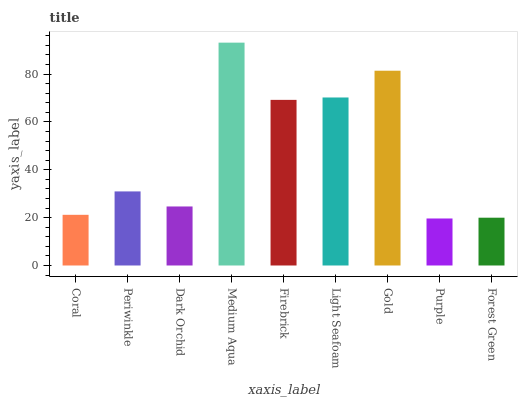Is Periwinkle the minimum?
Answer yes or no. No. Is Periwinkle the maximum?
Answer yes or no. No. Is Periwinkle greater than Coral?
Answer yes or no. Yes. Is Coral less than Periwinkle?
Answer yes or no. Yes. Is Coral greater than Periwinkle?
Answer yes or no. No. Is Periwinkle less than Coral?
Answer yes or no. No. Is Periwinkle the high median?
Answer yes or no. Yes. Is Periwinkle the low median?
Answer yes or no. Yes. Is Forest Green the high median?
Answer yes or no. No. Is Medium Aqua the low median?
Answer yes or no. No. 